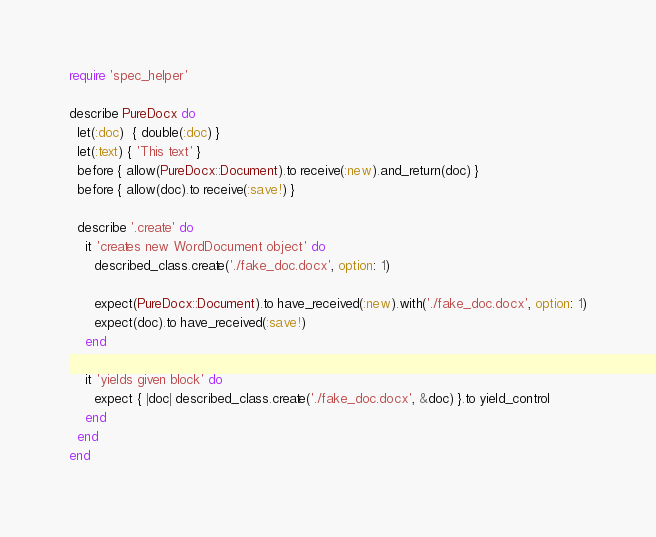<code> <loc_0><loc_0><loc_500><loc_500><_Ruby_>require 'spec_helper'

describe PureDocx do
  let(:doc)  { double(:doc) }
  let(:text) { 'This text' }
  before { allow(PureDocx::Document).to receive(:new).and_return(doc) }
  before { allow(doc).to receive(:save!) }

  describe '.create' do
    it 'creates new WordDocument object' do
      described_class.create('./fake_doc.docx', option: 1)

      expect(PureDocx::Document).to have_received(:new).with('./fake_doc.docx', option: 1)
      expect(doc).to have_received(:save!)
    end

    it 'yields given block' do
      expect { |doc| described_class.create('./fake_doc.docx', &doc) }.to yield_control
    end
  end
end
</code> 